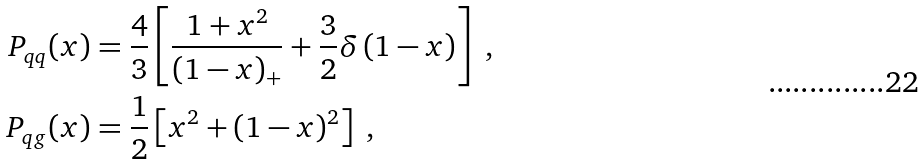Convert formula to latex. <formula><loc_0><loc_0><loc_500><loc_500>P _ { q q } ( x ) & = \frac { 4 } { 3 } \left [ \frac { 1 + x ^ { 2 } } { \left ( 1 - x \right ) _ { + } } + \frac { 3 } { 2 } \delta \left ( 1 - x \right ) \right ] \ , \\ P _ { q g } ( x ) & = \frac { 1 } { 2 } \left [ x ^ { 2 } + ( 1 - x ) ^ { 2 } \right ] \ ,</formula> 